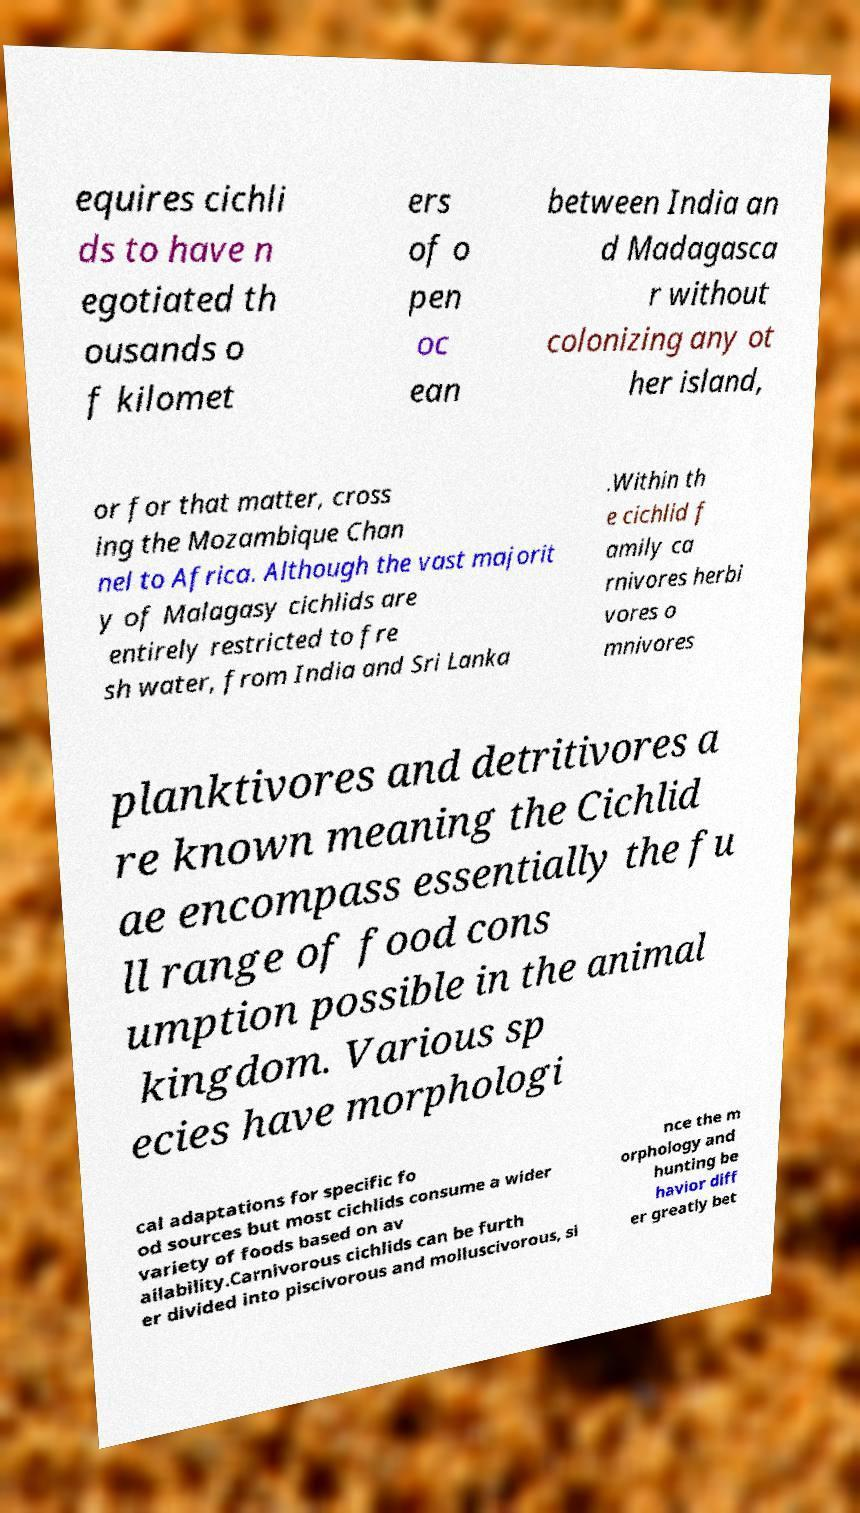Could you assist in decoding the text presented in this image and type it out clearly? equires cichli ds to have n egotiated th ousands o f kilomet ers of o pen oc ean between India an d Madagasca r without colonizing any ot her island, or for that matter, cross ing the Mozambique Chan nel to Africa. Although the vast majorit y of Malagasy cichlids are entirely restricted to fre sh water, from India and Sri Lanka .Within th e cichlid f amily ca rnivores herbi vores o mnivores planktivores and detritivores a re known meaning the Cichlid ae encompass essentially the fu ll range of food cons umption possible in the animal kingdom. Various sp ecies have morphologi cal adaptations for specific fo od sources but most cichlids consume a wider variety of foods based on av ailability.Carnivorous cichlids can be furth er divided into piscivorous and molluscivorous, si nce the m orphology and hunting be havior diff er greatly bet 